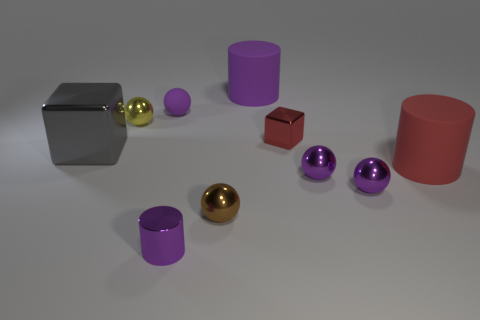Subtract all purple matte balls. How many balls are left? 4 Subtract all cylinders. How many objects are left? 7 Subtract all blue cylinders. How many brown balls are left? 1 Subtract all gray balls. Subtract all tiny red blocks. How many objects are left? 9 Add 4 red cylinders. How many red cylinders are left? 5 Add 2 small cyan things. How many small cyan things exist? 2 Subtract all yellow spheres. How many spheres are left? 4 Subtract 1 red cylinders. How many objects are left? 9 Subtract 2 spheres. How many spheres are left? 3 Subtract all cyan spheres. Subtract all yellow cylinders. How many spheres are left? 5 